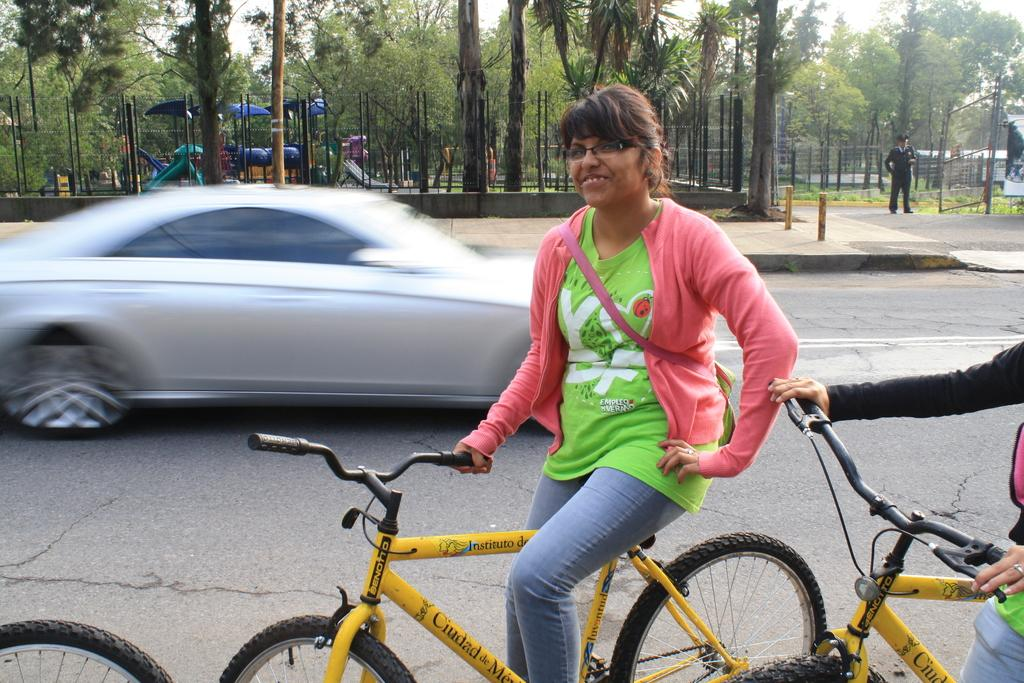What is the girl in the image doing? The girl is riding a bicycle in the image. What can be seen in the background of the image? There is a car running and trees visible in the background of the image. What type of barrier is present in the image? There is fencing in the image. Where is the policeman located in the image? The policeman is on the right side of the image. What type of prose is being recited by the girl on the bicycle in the image? There is no indication in the image that the girl is reciting any prose. How many cents can be seen on the ground near the bicycle in the image? There are no cents visible on the ground in the image. 